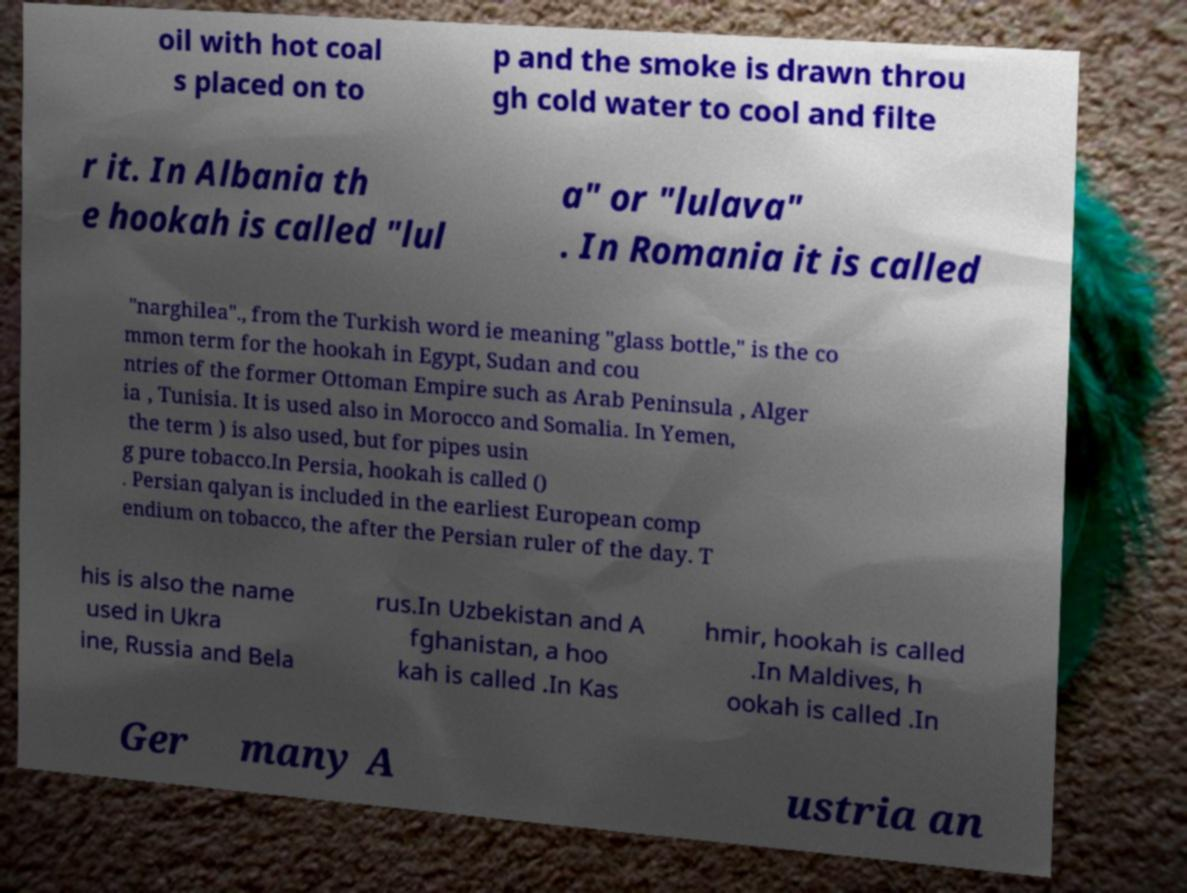Could you assist in decoding the text presented in this image and type it out clearly? oil with hot coal s placed on to p and the smoke is drawn throu gh cold water to cool and filte r it. In Albania th e hookah is called "lul a" or "lulava" . In Romania it is called "narghilea"., from the Turkish word ie meaning "glass bottle," is the co mmon term for the hookah in Egypt, Sudan and cou ntries of the former Ottoman Empire such as Arab Peninsula , Alger ia , Tunisia. It is used also in Morocco and Somalia. In Yemen, the term ) is also used, but for pipes usin g pure tobacco.In Persia, hookah is called () . Persian qalyan is included in the earliest European comp endium on tobacco, the after the Persian ruler of the day. T his is also the name used in Ukra ine, Russia and Bela rus.In Uzbekistan and A fghanistan, a hoo kah is called .In Kas hmir, hookah is called .In Maldives, h ookah is called .In Ger many A ustria an 